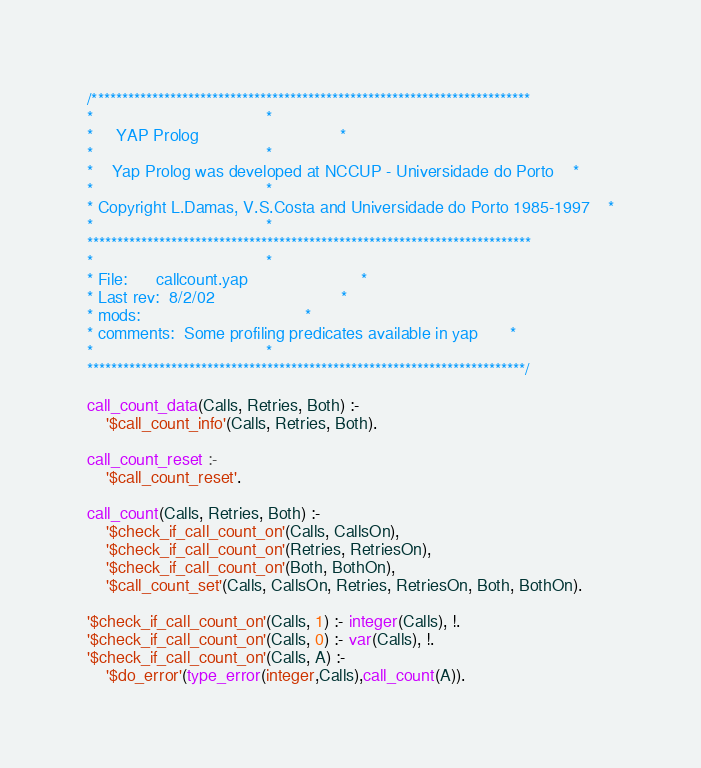<code> <loc_0><loc_0><loc_500><loc_500><_Prolog_>/*************************************************************************
*									 *
*	 YAP Prolog 							 *
*									 *
*	Yap Prolog was developed at NCCUP - Universidade do Porto	 *
*									 *
* Copyright L.Damas, V.S.Costa and Universidade do Porto 1985-1997	 *
*									 *
**************************************************************************
*									 *
* File:		callcount.yap						 *
* Last rev:	8/2/02							 *
* mods:									 *
* comments:	Some profiling predicates available in yap		 *
*									 *
*************************************************************************/

call_count_data(Calls, Retries, Both) :-
	'$call_count_info'(Calls, Retries, Both).

call_count_reset :-
	'$call_count_reset'.

call_count(Calls, Retries, Both) :-
	'$check_if_call_count_on'(Calls, CallsOn),
	'$check_if_call_count_on'(Retries, RetriesOn),
	'$check_if_call_count_on'(Both, BothOn),
	'$call_count_set'(Calls, CallsOn, Retries, RetriesOn, Both, BothOn).

'$check_if_call_count_on'(Calls, 1) :- integer(Calls), !.
'$check_if_call_count_on'(Calls, 0) :- var(Calls), !.
'$check_if_call_count_on'(Calls, A) :-
	'$do_error'(type_error(integer,Calls),call_count(A)).



</code> 